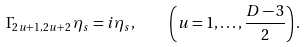Convert formula to latex. <formula><loc_0><loc_0><loc_500><loc_500>\Gamma _ { 2 u + 1 , 2 u + 2 } \, \eta _ { s } = i \eta _ { s } , \quad \left ( u = 1 , \dots , \frac { D - 3 } { 2 } \right ) .</formula> 